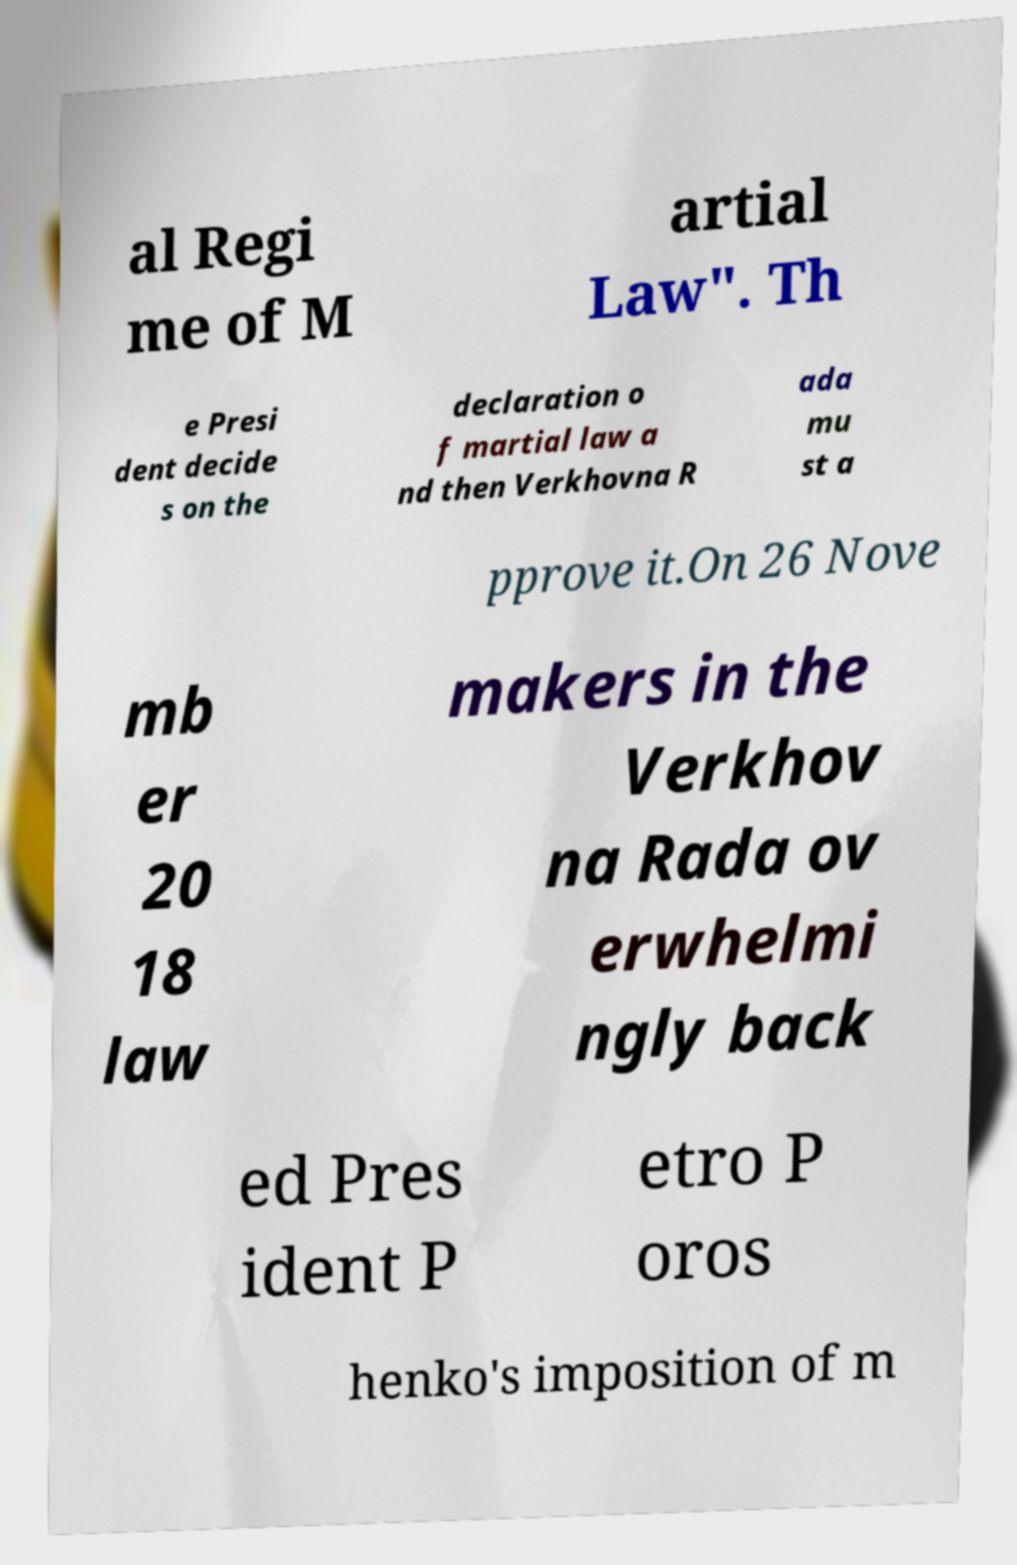For documentation purposes, I need the text within this image transcribed. Could you provide that? al Regi me of M artial Law". Th e Presi dent decide s on the declaration o f martial law a nd then Verkhovna R ada mu st a pprove it.On 26 Nove mb er 20 18 law makers in the Verkhov na Rada ov erwhelmi ngly back ed Pres ident P etro P oros henko's imposition of m 